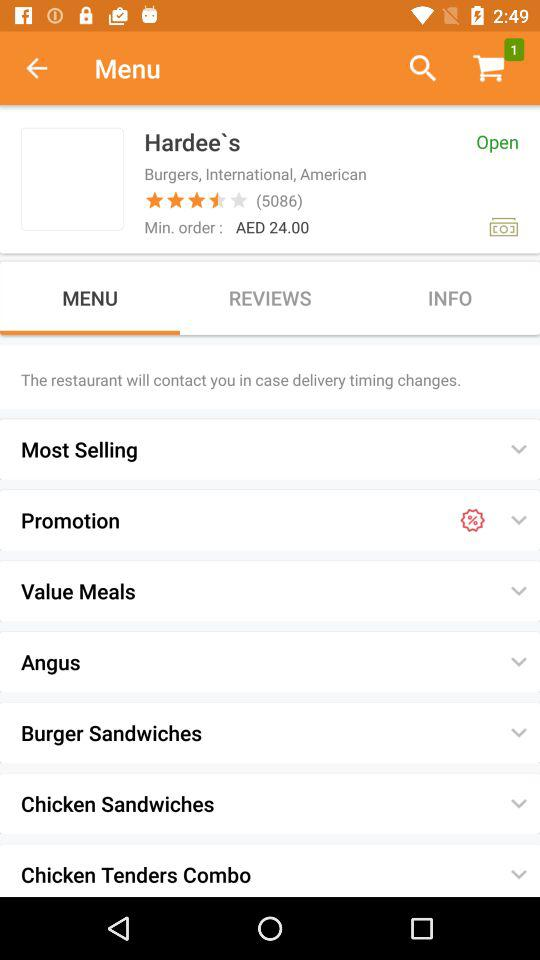What is the minimum order amount? The minimum order amount is AED 24.00. 